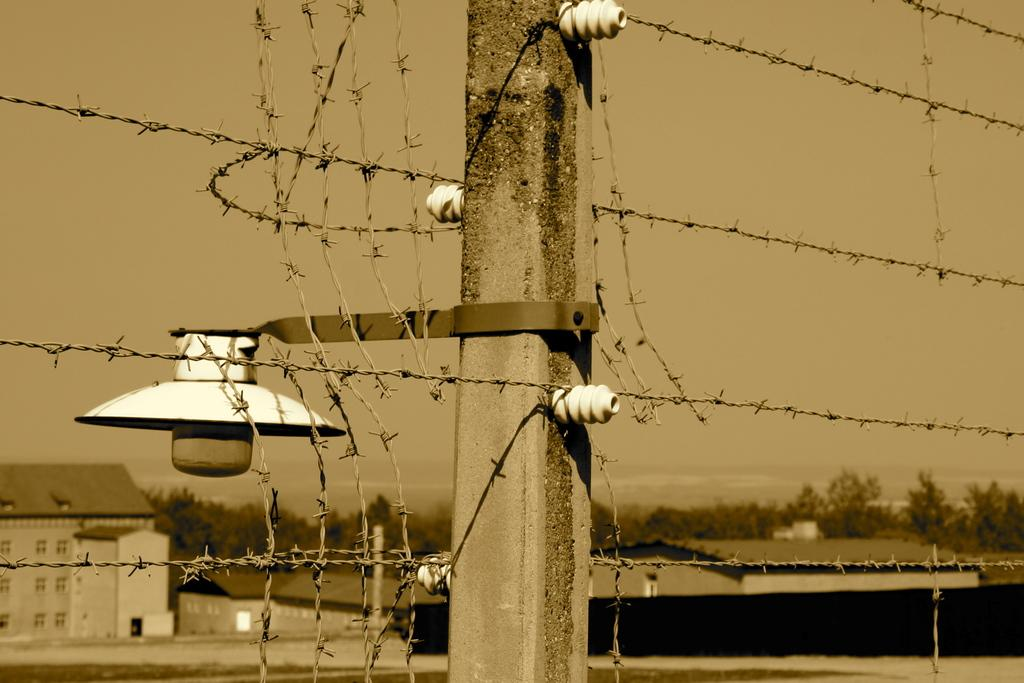What is the main object in the image? There is a pole in the image. What is attached to the pole on the left side? There is a lamp on the left side of the pole. What type of structures can be seen in the image? There are houses in the image. What type of vegetation is present in the image? There are trees in the image. How many nuts are hanging from the branches of the trees in the image? There are no nuts or branches mentioned in the image; it only features a pole, a lamp, houses, and trees. 